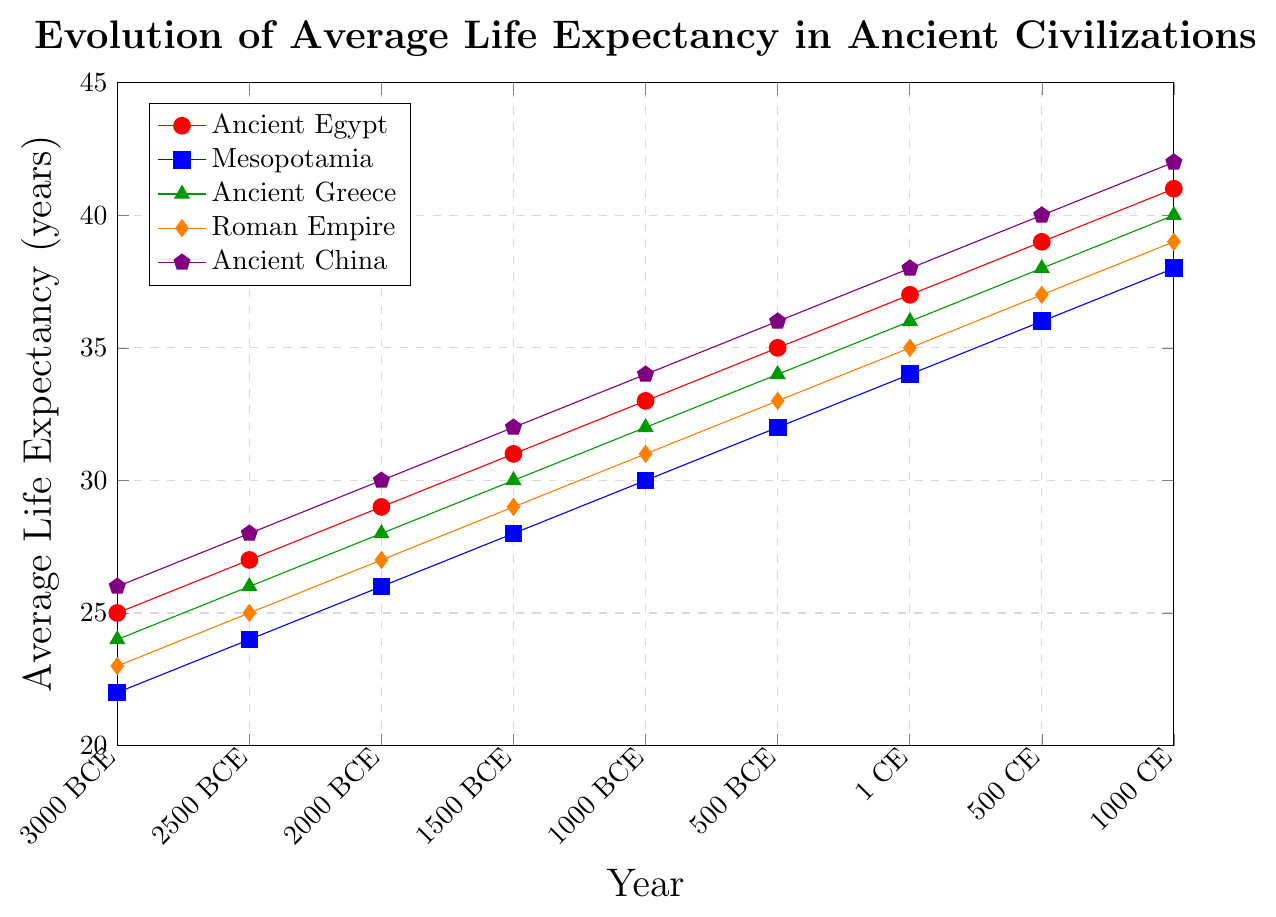What is the general trend observed in the average life expectancy for all civilizations depicted in the graph? To understand the general trend, observe the lines for each civilization from 3000 BCE to 1000 CE. All lines show an upward trajectory, indicating a gradual increase in average life expectancy over time for all the ancient civilizations.
Answer: Increasing trend Which civilization had the highest average life expectancy in 1 CE? Identify the point corresponding to 1 CE on the x-axis and look at the y-values for each civilization. Ancient China has the highest y-value at this point, indicating the highest average life expectancy.
Answer: Ancient China By how many years did the average life expectancy increase in Ancient Egypt from 3000 BCE to 1000 CE? Subtract the average life expectancy of Ancient Egypt in 3000 BCE (25 years) from that in 1000 CE (41 years): 41 - 25 equals 16.
Answer: 16 years Which civilization shows the smallest increase in average life expectancy from 2000 BCE to 500 CE? Calculate the increase for each civilization in this period: 
Ancient Egypt: 37 - 29 = 8 
Mesopotamia: 36 - 26 = 10 
Ancient Greece: 38 - 28 = 10 
Roman Empire: 37 - 27 = 10 
Ancient China: 40 - 30 = 10 
The smallest increase is for Ancient Egypt with 8 years.
Answer: Ancient Egypt At what point in time did Ancient China achieve a life expectancy of 34 years? Locate the point where Ancient China's line intersects with the y-value of 34. This intersection occurs around 1000 BCE.
Answer: 1000 BCE How does the average life expectancy in Ancient Greece in 500 BCE compare to that in Roman Empire in the same year? Check the y-values for both civilizations in 500 BCE. In 500 BCE, Ancient Greece has a life expectancy of 34 years, and the Roman Empire has 33 years. 34 is greater than 33, so Ancient Greece's average life expectancy was higher.
Answer: Higher Between Ancient Greece and Mesopotamia, which civilization's life expectancy grew faster from 1000 BCE to 1 CE? Calculate the increase for each civilization in this period: 
Ancient Greece: 36 - 32 = 4 
Mesopotamia: 34 - 30 = 4 
Both civilizations had the same increase, 4 years, indicating similar growth rates in this period.
Answer: Same rate Estimate the average life expectancy improvement per century for Ancient China from 3000 BCE to 1000 CE. Calculate the total increase over the entire period (42 - 26 = 16 years) and the number of centuries (40 centuries) from 3000 BCE to 1000 CE. The average improvement per century is 16 / 40 = 0.4 years.
Answer: 0.4 years per century 